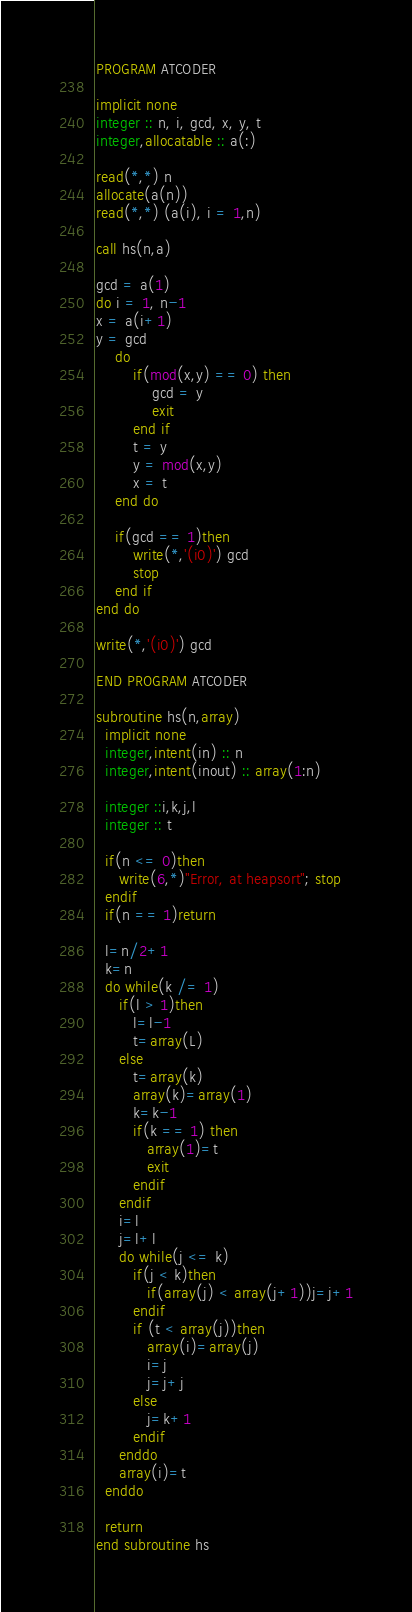Convert code to text. <code><loc_0><loc_0><loc_500><loc_500><_FORTRAN_>PROGRAM ATCODER

implicit none
integer :: n, i, gcd, x, y, t
integer,allocatable :: a(:)

read(*,*) n
allocate(a(n))
read(*,*) (a(i), i = 1,n)

call hs(n,a)

gcd = a(1)
do i = 1, n-1
x = a(i+1)
y = gcd
	do 
    	if(mod(x,y) == 0) then
        	gcd = y
            exit
		end if
        t = y
        y = mod(x,y)
        x = t
    end do
    
    if(gcd == 1)then
    	write(*,'(i0)') gcd
        stop
    end if
end do

write(*,'(i0)') gcd
 
END PROGRAM ATCODER

subroutine hs(n,array)
  implicit none
  integer,intent(in) :: n
  integer,intent(inout) :: array(1:n)
  
  integer ::i,k,j,l
  integer :: t
  
  if(n <= 0)then
     write(6,*)"Error, at heapsort"; stop
  endif
  if(n == 1)return
 
  l=n/2+1
  k=n
  do while(k /= 1)
     if(l > 1)then
        l=l-1
        t=array(L)
     else
        t=array(k)
        array(k)=array(1)
        k=k-1
        if(k == 1) then
           array(1)=t
           exit
        endif
     endif
     i=l
     j=l+l
     do while(j <= k)
        if(j < k)then
           if(array(j) < array(j+1))j=j+1
        endif
        if (t < array(j))then
           array(i)=array(j)
           i=j
           j=j+j
        else
           j=k+1
        endif
     enddo
     array(i)=t
  enddo
 
  return
end subroutine hs</code> 